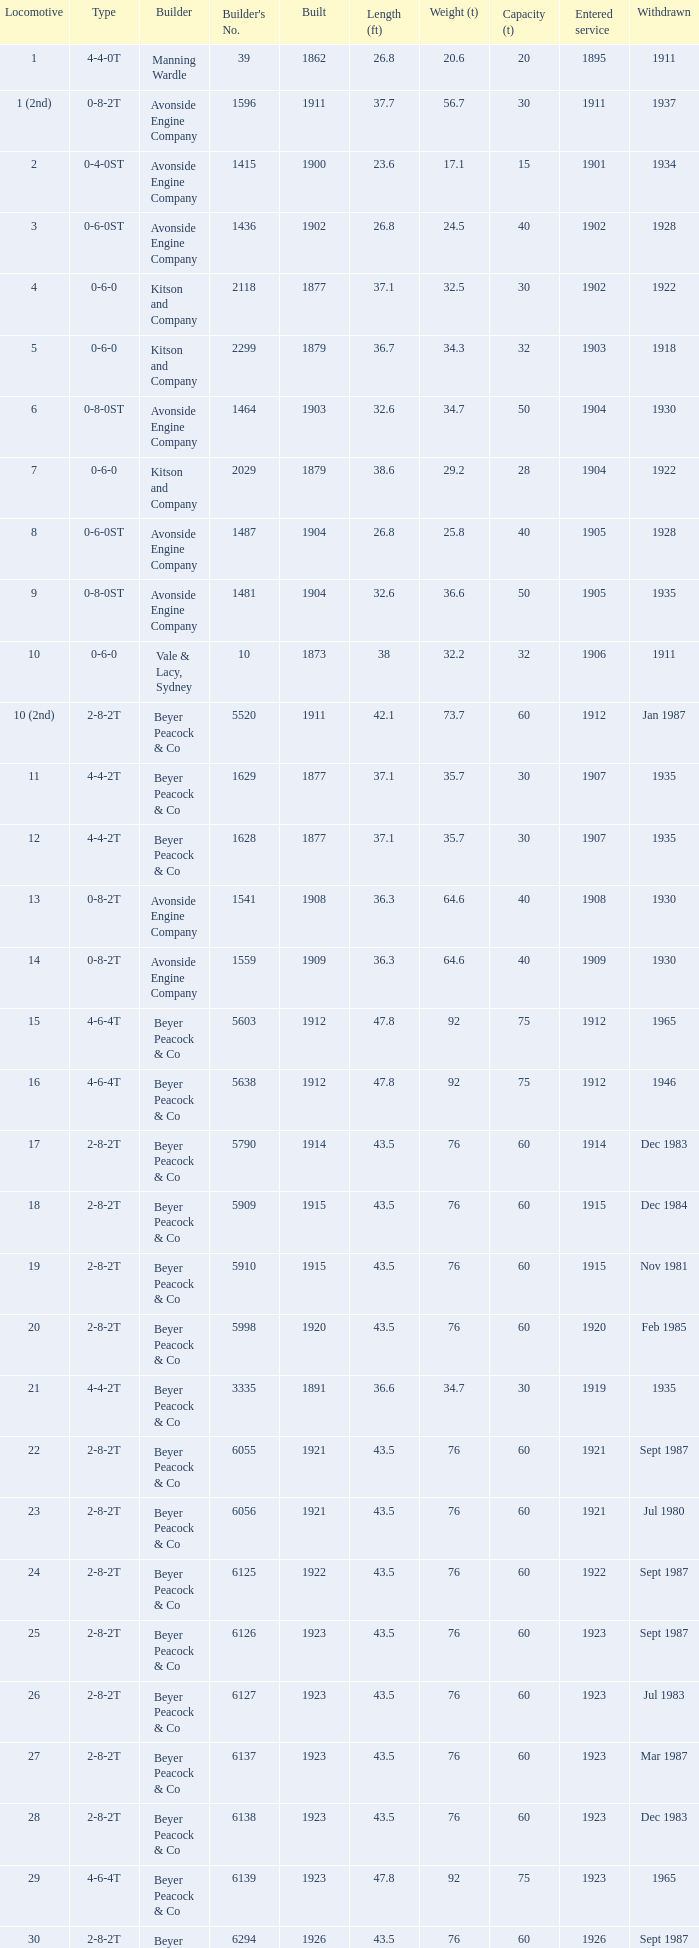How many years entered service when there were 13 locomotives? 1.0. 